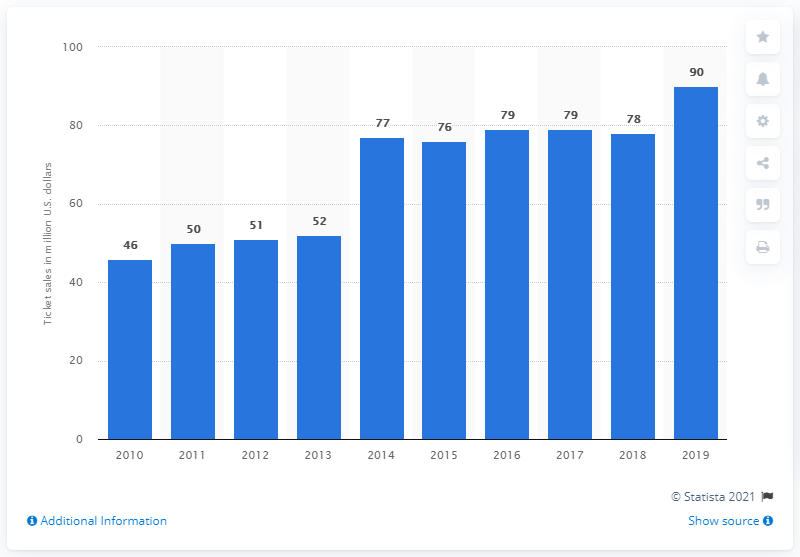List a handful of essential elements in this visual. The San Francisco 49ers generated approximately $90 million in gate receipts in 2019. 